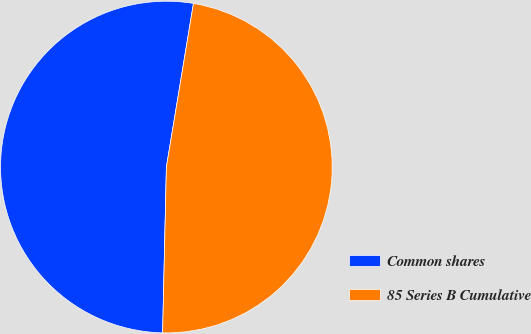<chart> <loc_0><loc_0><loc_500><loc_500><pie_chart><fcel>Common shares<fcel>85 Series B Cumulative<nl><fcel>52.25%<fcel>47.75%<nl></chart> 